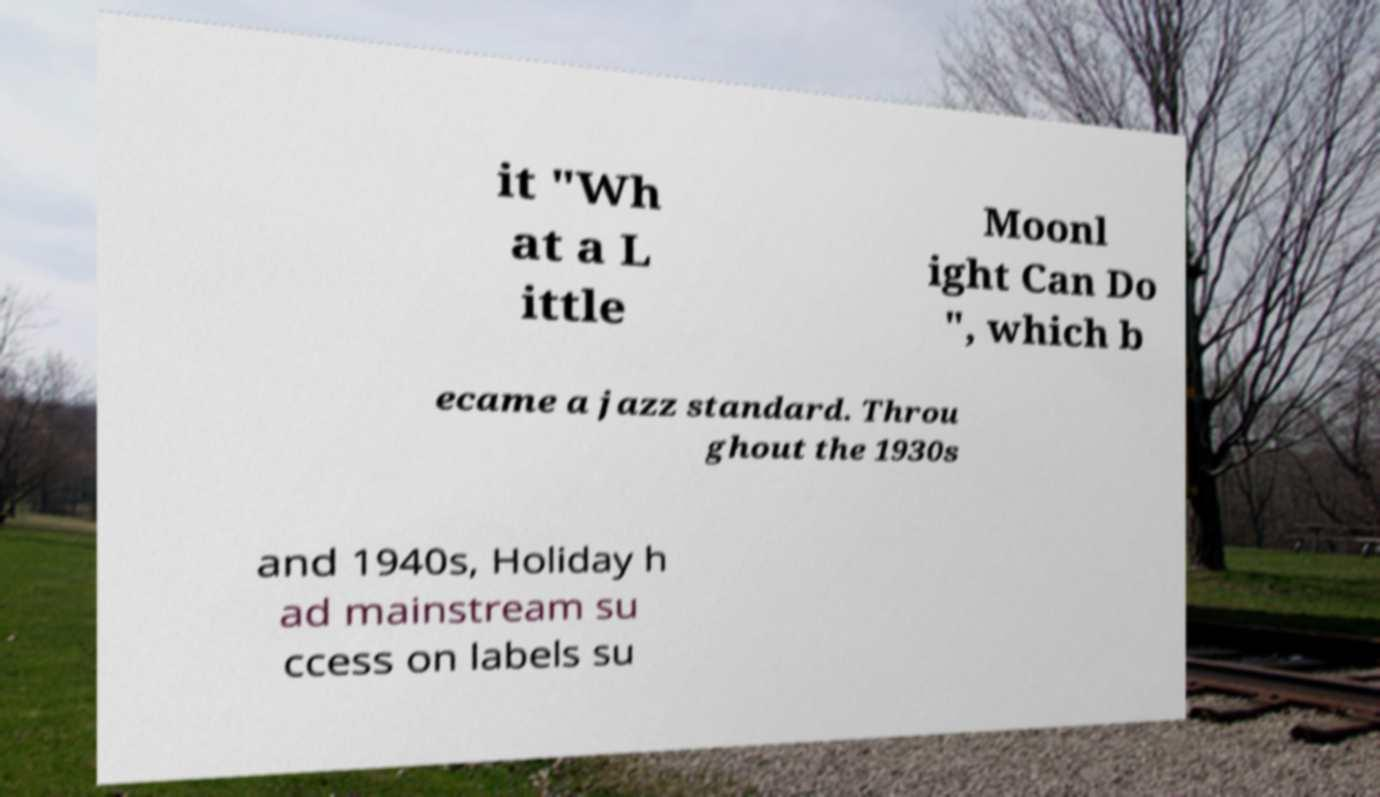There's text embedded in this image that I need extracted. Can you transcribe it verbatim? it "Wh at a L ittle Moonl ight Can Do ", which b ecame a jazz standard. Throu ghout the 1930s and 1940s, Holiday h ad mainstream su ccess on labels su 